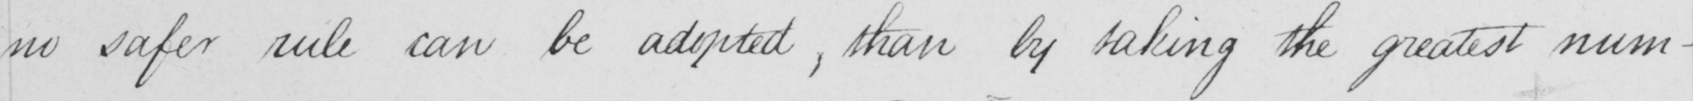Transcribe the text shown in this historical manuscript line. no safer rule can be adopted , than by taking the greatest num- 